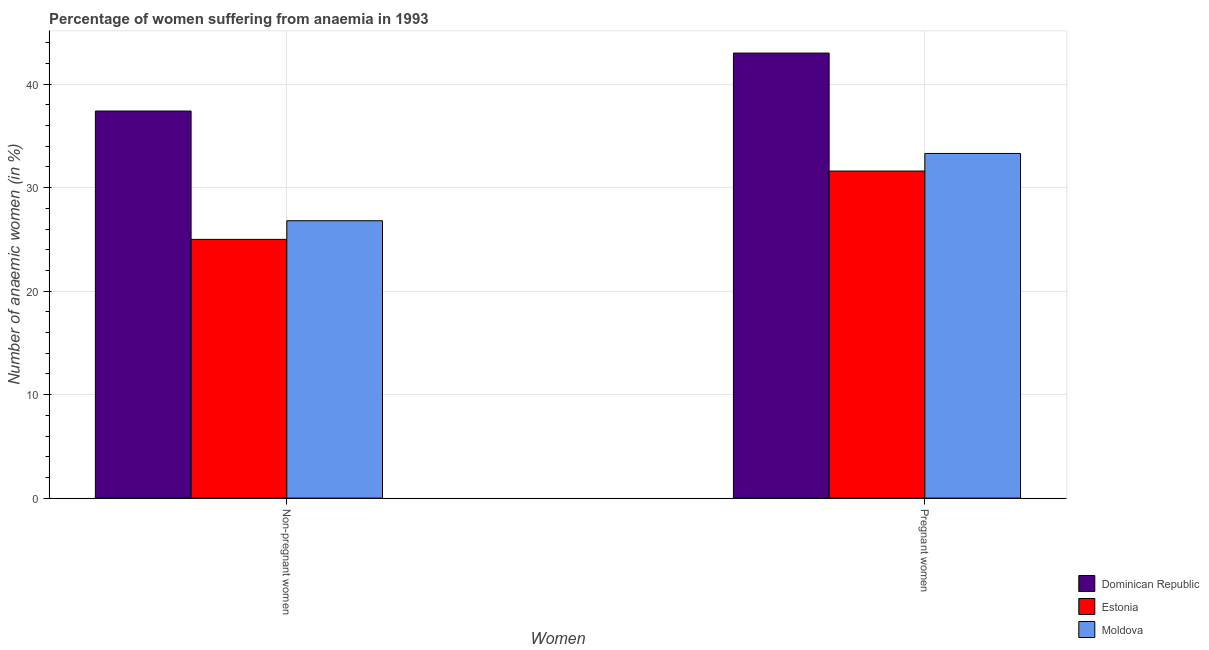How many different coloured bars are there?
Keep it short and to the point. 3. Are the number of bars per tick equal to the number of legend labels?
Give a very brief answer. Yes. Are the number of bars on each tick of the X-axis equal?
Provide a succinct answer. Yes. How many bars are there on the 2nd tick from the left?
Make the answer very short. 3. What is the label of the 2nd group of bars from the left?
Offer a terse response. Pregnant women. What is the percentage of non-pregnant anaemic women in Dominican Republic?
Your answer should be very brief. 37.4. Across all countries, what is the maximum percentage of non-pregnant anaemic women?
Provide a short and direct response. 37.4. Across all countries, what is the minimum percentage of non-pregnant anaemic women?
Your answer should be compact. 25. In which country was the percentage of pregnant anaemic women maximum?
Provide a succinct answer. Dominican Republic. In which country was the percentage of pregnant anaemic women minimum?
Your answer should be compact. Estonia. What is the total percentage of non-pregnant anaemic women in the graph?
Ensure brevity in your answer.  89.2. What is the difference between the percentage of non-pregnant anaemic women in Dominican Republic and that in Moldova?
Make the answer very short. 10.6. What is the difference between the percentage of non-pregnant anaemic women in Moldova and the percentage of pregnant anaemic women in Estonia?
Your answer should be compact. -4.8. What is the average percentage of pregnant anaemic women per country?
Your answer should be very brief. 35.97. What is the difference between the percentage of non-pregnant anaemic women and percentage of pregnant anaemic women in Moldova?
Ensure brevity in your answer.  -6.5. In how many countries, is the percentage of pregnant anaemic women greater than 4 %?
Make the answer very short. 3. What is the ratio of the percentage of non-pregnant anaemic women in Dominican Republic to that in Estonia?
Give a very brief answer. 1.5. What does the 3rd bar from the left in Non-pregnant women represents?
Offer a very short reply. Moldova. What does the 1st bar from the right in Non-pregnant women represents?
Ensure brevity in your answer.  Moldova. How many bars are there?
Ensure brevity in your answer.  6. What is the difference between two consecutive major ticks on the Y-axis?
Provide a short and direct response. 10. Does the graph contain grids?
Provide a short and direct response. Yes. Where does the legend appear in the graph?
Provide a succinct answer. Bottom right. How many legend labels are there?
Ensure brevity in your answer.  3. How are the legend labels stacked?
Make the answer very short. Vertical. What is the title of the graph?
Provide a succinct answer. Percentage of women suffering from anaemia in 1993. What is the label or title of the X-axis?
Keep it short and to the point. Women. What is the label or title of the Y-axis?
Give a very brief answer. Number of anaemic women (in %). What is the Number of anaemic women (in %) of Dominican Republic in Non-pregnant women?
Provide a short and direct response. 37.4. What is the Number of anaemic women (in %) in Moldova in Non-pregnant women?
Ensure brevity in your answer.  26.8. What is the Number of anaemic women (in %) of Dominican Republic in Pregnant women?
Offer a terse response. 43. What is the Number of anaemic women (in %) in Estonia in Pregnant women?
Offer a very short reply. 31.6. What is the Number of anaemic women (in %) in Moldova in Pregnant women?
Offer a terse response. 33.3. Across all Women, what is the maximum Number of anaemic women (in %) of Dominican Republic?
Your response must be concise. 43. Across all Women, what is the maximum Number of anaemic women (in %) in Estonia?
Your answer should be compact. 31.6. Across all Women, what is the maximum Number of anaemic women (in %) of Moldova?
Keep it short and to the point. 33.3. Across all Women, what is the minimum Number of anaemic women (in %) of Dominican Republic?
Give a very brief answer. 37.4. Across all Women, what is the minimum Number of anaemic women (in %) in Estonia?
Keep it short and to the point. 25. Across all Women, what is the minimum Number of anaemic women (in %) of Moldova?
Offer a very short reply. 26.8. What is the total Number of anaemic women (in %) of Dominican Republic in the graph?
Your response must be concise. 80.4. What is the total Number of anaemic women (in %) in Estonia in the graph?
Provide a succinct answer. 56.6. What is the total Number of anaemic women (in %) of Moldova in the graph?
Provide a short and direct response. 60.1. What is the difference between the Number of anaemic women (in %) in Moldova in Non-pregnant women and that in Pregnant women?
Keep it short and to the point. -6.5. What is the average Number of anaemic women (in %) in Dominican Republic per Women?
Your answer should be very brief. 40.2. What is the average Number of anaemic women (in %) of Estonia per Women?
Offer a very short reply. 28.3. What is the average Number of anaemic women (in %) in Moldova per Women?
Provide a succinct answer. 30.05. What is the difference between the Number of anaemic women (in %) of Dominican Republic and Number of anaemic women (in %) of Estonia in Non-pregnant women?
Offer a terse response. 12.4. What is the difference between the Number of anaemic women (in %) of Estonia and Number of anaemic women (in %) of Moldova in Non-pregnant women?
Ensure brevity in your answer.  -1.8. What is the difference between the Number of anaemic women (in %) of Dominican Republic and Number of anaemic women (in %) of Estonia in Pregnant women?
Your answer should be very brief. 11.4. What is the difference between the Number of anaemic women (in %) in Dominican Republic and Number of anaemic women (in %) in Moldova in Pregnant women?
Offer a very short reply. 9.7. What is the ratio of the Number of anaemic women (in %) in Dominican Republic in Non-pregnant women to that in Pregnant women?
Give a very brief answer. 0.87. What is the ratio of the Number of anaemic women (in %) in Estonia in Non-pregnant women to that in Pregnant women?
Offer a very short reply. 0.79. What is the ratio of the Number of anaemic women (in %) of Moldova in Non-pregnant women to that in Pregnant women?
Make the answer very short. 0.8. What is the difference between the highest and the second highest Number of anaemic women (in %) in Dominican Republic?
Your answer should be very brief. 5.6. What is the difference between the highest and the second highest Number of anaemic women (in %) in Estonia?
Offer a very short reply. 6.6. What is the difference between the highest and the lowest Number of anaemic women (in %) in Dominican Republic?
Your answer should be very brief. 5.6. What is the difference between the highest and the lowest Number of anaemic women (in %) of Moldova?
Offer a terse response. 6.5. 